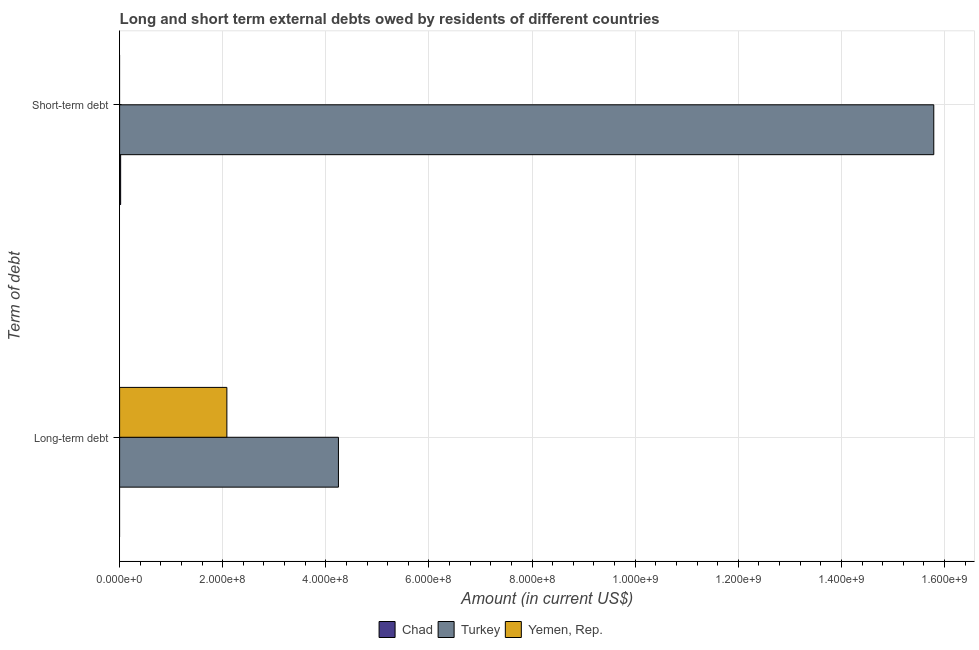Are the number of bars per tick equal to the number of legend labels?
Give a very brief answer. No. Are the number of bars on each tick of the Y-axis equal?
Provide a short and direct response. Yes. How many bars are there on the 1st tick from the top?
Make the answer very short. 2. How many bars are there on the 2nd tick from the bottom?
Give a very brief answer. 2. What is the label of the 1st group of bars from the top?
Provide a succinct answer. Short-term debt. What is the short-term debts owed by residents in Yemen, Rep.?
Keep it short and to the point. 0. Across all countries, what is the maximum long-term debts owed by residents?
Your answer should be very brief. 4.24e+08. Across all countries, what is the minimum long-term debts owed by residents?
Keep it short and to the point. 0. What is the total short-term debts owed by residents in the graph?
Provide a succinct answer. 1.58e+09. What is the difference between the short-term debts owed by residents in Turkey and that in Chad?
Ensure brevity in your answer.  1.58e+09. What is the difference between the short-term debts owed by residents in Yemen, Rep. and the long-term debts owed by residents in Chad?
Provide a succinct answer. 0. What is the average long-term debts owed by residents per country?
Your answer should be compact. 2.11e+08. What is the difference between the short-term debts owed by residents and long-term debts owed by residents in Turkey?
Make the answer very short. 1.15e+09. In how many countries, is the short-term debts owed by residents greater than 1280000000 US$?
Your answer should be compact. 1. How many bars are there?
Your answer should be very brief. 4. Are all the bars in the graph horizontal?
Provide a succinct answer. Yes. Does the graph contain any zero values?
Keep it short and to the point. Yes. Does the graph contain grids?
Offer a very short reply. Yes. Where does the legend appear in the graph?
Provide a short and direct response. Bottom center. How many legend labels are there?
Offer a terse response. 3. How are the legend labels stacked?
Your answer should be very brief. Horizontal. What is the title of the graph?
Your answer should be compact. Long and short term external debts owed by residents of different countries. Does "Micronesia" appear as one of the legend labels in the graph?
Provide a succinct answer. No. What is the label or title of the X-axis?
Make the answer very short. Amount (in current US$). What is the label or title of the Y-axis?
Offer a terse response. Term of debt. What is the Amount (in current US$) in Turkey in Long-term debt?
Your answer should be compact. 4.24e+08. What is the Amount (in current US$) in Yemen, Rep. in Long-term debt?
Give a very brief answer. 2.08e+08. What is the Amount (in current US$) of Chad in Short-term debt?
Your answer should be very brief. 2.00e+06. What is the Amount (in current US$) in Turkey in Short-term debt?
Your answer should be very brief. 1.58e+09. Across all Term of debt, what is the maximum Amount (in current US$) of Turkey?
Provide a succinct answer. 1.58e+09. Across all Term of debt, what is the maximum Amount (in current US$) of Yemen, Rep.?
Keep it short and to the point. 2.08e+08. Across all Term of debt, what is the minimum Amount (in current US$) of Chad?
Your answer should be compact. 0. Across all Term of debt, what is the minimum Amount (in current US$) in Turkey?
Offer a very short reply. 4.24e+08. Across all Term of debt, what is the minimum Amount (in current US$) of Yemen, Rep.?
Provide a short and direct response. 0. What is the total Amount (in current US$) of Chad in the graph?
Make the answer very short. 2.00e+06. What is the total Amount (in current US$) in Turkey in the graph?
Offer a very short reply. 2.00e+09. What is the total Amount (in current US$) of Yemen, Rep. in the graph?
Offer a terse response. 2.08e+08. What is the difference between the Amount (in current US$) in Turkey in Long-term debt and that in Short-term debt?
Your answer should be compact. -1.15e+09. What is the average Amount (in current US$) of Chad per Term of debt?
Your response must be concise. 1.00e+06. What is the average Amount (in current US$) of Turkey per Term of debt?
Your response must be concise. 1.00e+09. What is the average Amount (in current US$) of Yemen, Rep. per Term of debt?
Make the answer very short. 1.04e+08. What is the difference between the Amount (in current US$) in Turkey and Amount (in current US$) in Yemen, Rep. in Long-term debt?
Offer a terse response. 2.16e+08. What is the difference between the Amount (in current US$) of Chad and Amount (in current US$) of Turkey in Short-term debt?
Offer a terse response. -1.58e+09. What is the ratio of the Amount (in current US$) in Turkey in Long-term debt to that in Short-term debt?
Ensure brevity in your answer.  0.27. What is the difference between the highest and the second highest Amount (in current US$) of Turkey?
Give a very brief answer. 1.15e+09. What is the difference between the highest and the lowest Amount (in current US$) in Turkey?
Your answer should be compact. 1.15e+09. What is the difference between the highest and the lowest Amount (in current US$) in Yemen, Rep.?
Your response must be concise. 2.08e+08. 